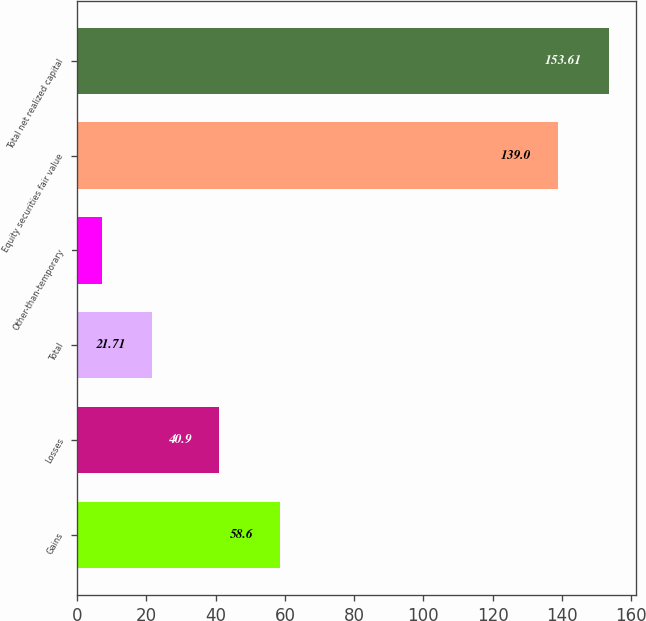Convert chart. <chart><loc_0><loc_0><loc_500><loc_500><bar_chart><fcel>Gains<fcel>Losses<fcel>Total<fcel>Other-than-temporary<fcel>Equity securities fair value<fcel>Total net realized capital<nl><fcel>58.6<fcel>40.9<fcel>21.71<fcel>7.1<fcel>139<fcel>153.61<nl></chart> 